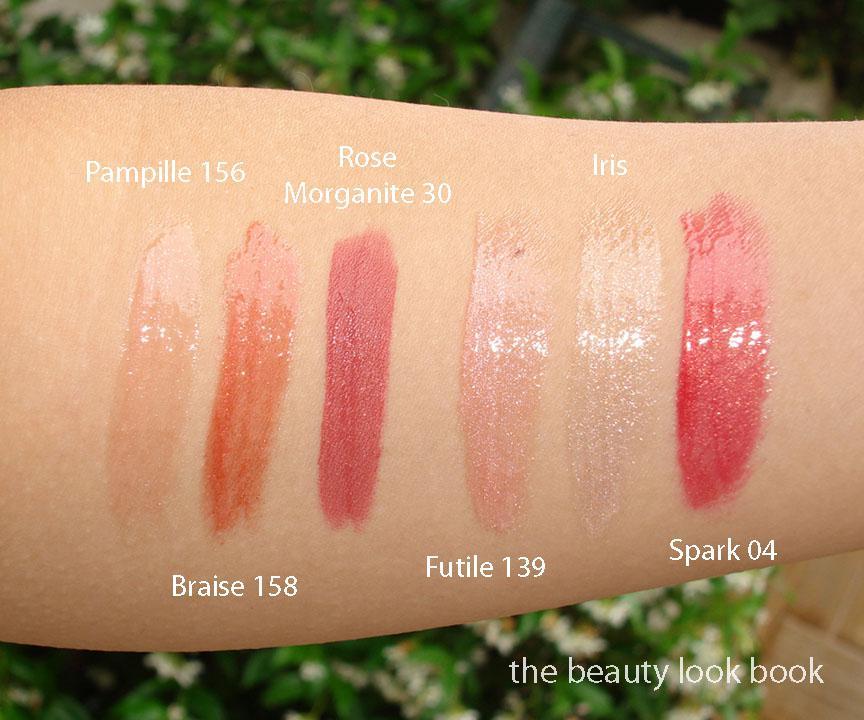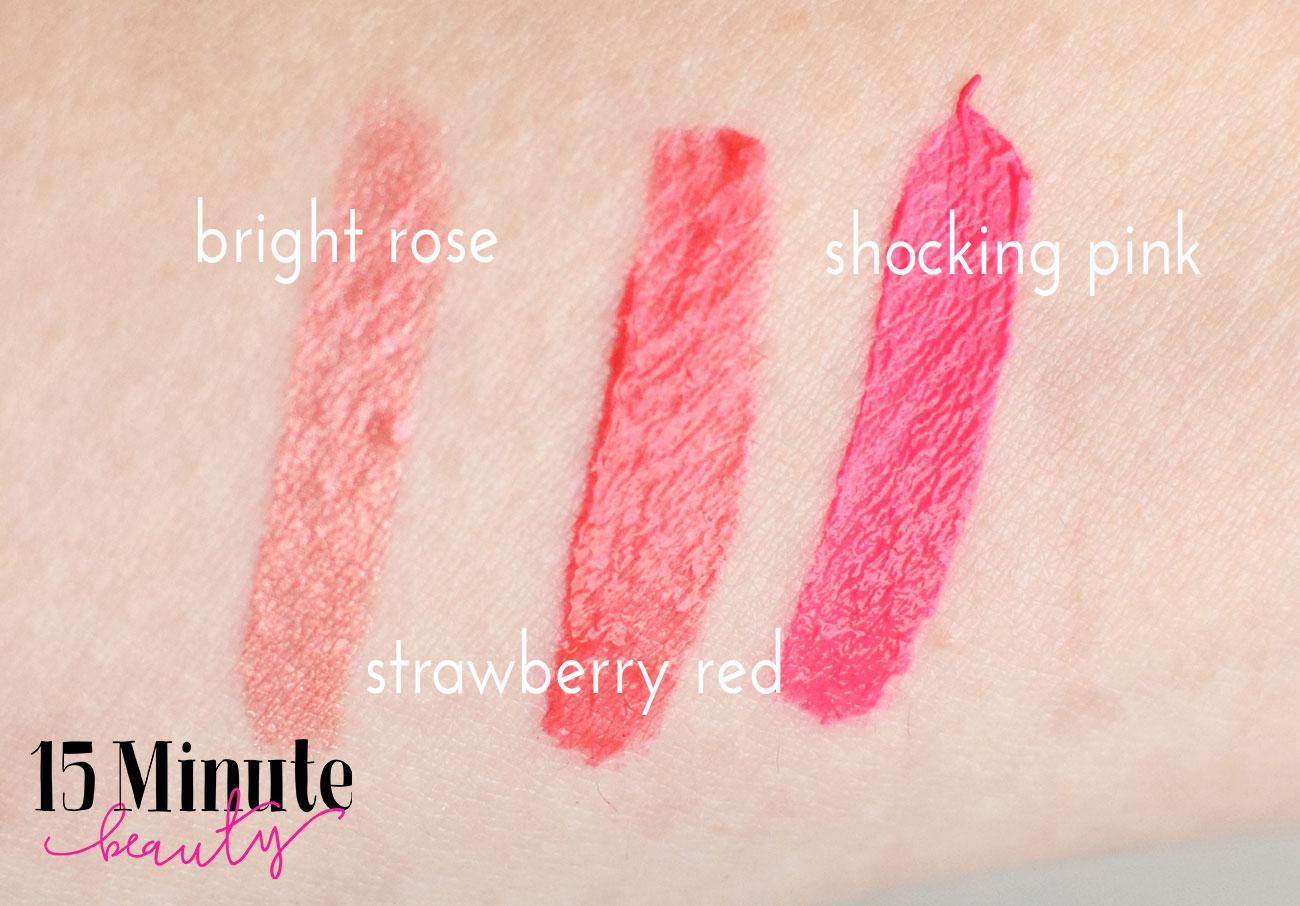The first image is the image on the left, the second image is the image on the right. Examine the images to the left and right. Is the description "One picture shows six or more pigments of lipstick swatched on a human arm." accurate? Answer yes or no. Yes. The first image is the image on the left, the second image is the image on the right. Considering the images on both sides, is "In each image, different shades of lipstick are displayed alongside each other on a human arm" valid? Answer yes or no. Yes. 